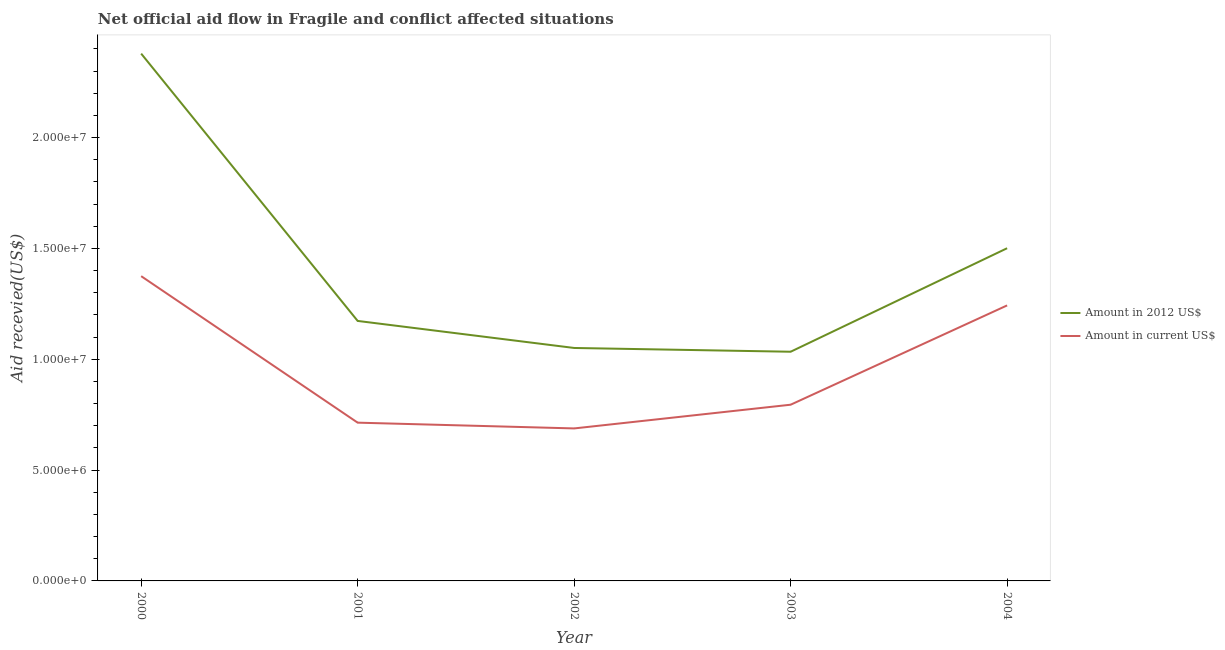How many different coloured lines are there?
Your answer should be very brief. 2. Does the line corresponding to amount of aid received(expressed in 2012 us$) intersect with the line corresponding to amount of aid received(expressed in us$)?
Make the answer very short. No. Is the number of lines equal to the number of legend labels?
Keep it short and to the point. Yes. What is the amount of aid received(expressed in 2012 us$) in 2000?
Offer a very short reply. 2.38e+07. Across all years, what is the maximum amount of aid received(expressed in 2012 us$)?
Make the answer very short. 2.38e+07. Across all years, what is the minimum amount of aid received(expressed in 2012 us$)?
Your answer should be very brief. 1.03e+07. In which year was the amount of aid received(expressed in us$) maximum?
Offer a very short reply. 2000. What is the total amount of aid received(expressed in 2012 us$) in the graph?
Your response must be concise. 7.14e+07. What is the difference between the amount of aid received(expressed in us$) in 2000 and that in 2001?
Ensure brevity in your answer.  6.61e+06. What is the difference between the amount of aid received(expressed in 2012 us$) in 2003 and the amount of aid received(expressed in us$) in 2002?
Your response must be concise. 3.46e+06. What is the average amount of aid received(expressed in us$) per year?
Make the answer very short. 9.63e+06. In the year 2003, what is the difference between the amount of aid received(expressed in us$) and amount of aid received(expressed in 2012 us$)?
Offer a very short reply. -2.39e+06. In how many years, is the amount of aid received(expressed in us$) greater than 20000000 US$?
Provide a short and direct response. 0. What is the ratio of the amount of aid received(expressed in us$) in 2002 to that in 2004?
Give a very brief answer. 0.55. What is the difference between the highest and the second highest amount of aid received(expressed in us$)?
Keep it short and to the point. 1.32e+06. What is the difference between the highest and the lowest amount of aid received(expressed in us$)?
Give a very brief answer. 6.87e+06. In how many years, is the amount of aid received(expressed in 2012 us$) greater than the average amount of aid received(expressed in 2012 us$) taken over all years?
Ensure brevity in your answer.  2. Does the amount of aid received(expressed in 2012 us$) monotonically increase over the years?
Offer a very short reply. No. Is the amount of aid received(expressed in us$) strictly greater than the amount of aid received(expressed in 2012 us$) over the years?
Ensure brevity in your answer.  No. Is the amount of aid received(expressed in 2012 us$) strictly less than the amount of aid received(expressed in us$) over the years?
Keep it short and to the point. No. How many lines are there?
Your answer should be very brief. 2. What is the difference between two consecutive major ticks on the Y-axis?
Give a very brief answer. 5.00e+06. Are the values on the major ticks of Y-axis written in scientific E-notation?
Offer a very short reply. Yes. Does the graph contain any zero values?
Your answer should be compact. No. Does the graph contain grids?
Make the answer very short. No. Where does the legend appear in the graph?
Give a very brief answer. Center right. What is the title of the graph?
Ensure brevity in your answer.  Net official aid flow in Fragile and conflict affected situations. What is the label or title of the X-axis?
Provide a succinct answer. Year. What is the label or title of the Y-axis?
Your response must be concise. Aid recevied(US$). What is the Aid recevied(US$) of Amount in 2012 US$ in 2000?
Your answer should be compact. 2.38e+07. What is the Aid recevied(US$) in Amount in current US$ in 2000?
Give a very brief answer. 1.38e+07. What is the Aid recevied(US$) in Amount in 2012 US$ in 2001?
Your answer should be compact. 1.17e+07. What is the Aid recevied(US$) in Amount in current US$ in 2001?
Your answer should be very brief. 7.14e+06. What is the Aid recevied(US$) of Amount in 2012 US$ in 2002?
Provide a succinct answer. 1.05e+07. What is the Aid recevied(US$) in Amount in current US$ in 2002?
Keep it short and to the point. 6.88e+06. What is the Aid recevied(US$) of Amount in 2012 US$ in 2003?
Provide a succinct answer. 1.03e+07. What is the Aid recevied(US$) in Amount in current US$ in 2003?
Ensure brevity in your answer.  7.95e+06. What is the Aid recevied(US$) in Amount in 2012 US$ in 2004?
Offer a terse response. 1.50e+07. What is the Aid recevied(US$) in Amount in current US$ in 2004?
Provide a short and direct response. 1.24e+07. Across all years, what is the maximum Aid recevied(US$) of Amount in 2012 US$?
Offer a very short reply. 2.38e+07. Across all years, what is the maximum Aid recevied(US$) in Amount in current US$?
Make the answer very short. 1.38e+07. Across all years, what is the minimum Aid recevied(US$) of Amount in 2012 US$?
Give a very brief answer. 1.03e+07. Across all years, what is the minimum Aid recevied(US$) in Amount in current US$?
Your response must be concise. 6.88e+06. What is the total Aid recevied(US$) in Amount in 2012 US$ in the graph?
Make the answer very short. 7.14e+07. What is the total Aid recevied(US$) in Amount in current US$ in the graph?
Ensure brevity in your answer.  4.82e+07. What is the difference between the Aid recevied(US$) in Amount in 2012 US$ in 2000 and that in 2001?
Keep it short and to the point. 1.21e+07. What is the difference between the Aid recevied(US$) in Amount in current US$ in 2000 and that in 2001?
Give a very brief answer. 6.61e+06. What is the difference between the Aid recevied(US$) in Amount in 2012 US$ in 2000 and that in 2002?
Provide a short and direct response. 1.33e+07. What is the difference between the Aid recevied(US$) of Amount in current US$ in 2000 and that in 2002?
Provide a short and direct response. 6.87e+06. What is the difference between the Aid recevied(US$) of Amount in 2012 US$ in 2000 and that in 2003?
Ensure brevity in your answer.  1.34e+07. What is the difference between the Aid recevied(US$) of Amount in current US$ in 2000 and that in 2003?
Provide a short and direct response. 5.80e+06. What is the difference between the Aid recevied(US$) in Amount in 2012 US$ in 2000 and that in 2004?
Offer a terse response. 8.78e+06. What is the difference between the Aid recevied(US$) of Amount in current US$ in 2000 and that in 2004?
Your answer should be compact. 1.32e+06. What is the difference between the Aid recevied(US$) in Amount in 2012 US$ in 2001 and that in 2002?
Provide a succinct answer. 1.22e+06. What is the difference between the Aid recevied(US$) in Amount in current US$ in 2001 and that in 2002?
Give a very brief answer. 2.60e+05. What is the difference between the Aid recevied(US$) in Amount in 2012 US$ in 2001 and that in 2003?
Your answer should be very brief. 1.39e+06. What is the difference between the Aid recevied(US$) of Amount in current US$ in 2001 and that in 2003?
Your answer should be very brief. -8.10e+05. What is the difference between the Aid recevied(US$) of Amount in 2012 US$ in 2001 and that in 2004?
Your answer should be very brief. -3.28e+06. What is the difference between the Aid recevied(US$) of Amount in current US$ in 2001 and that in 2004?
Give a very brief answer. -5.29e+06. What is the difference between the Aid recevied(US$) of Amount in 2012 US$ in 2002 and that in 2003?
Keep it short and to the point. 1.70e+05. What is the difference between the Aid recevied(US$) in Amount in current US$ in 2002 and that in 2003?
Your response must be concise. -1.07e+06. What is the difference between the Aid recevied(US$) of Amount in 2012 US$ in 2002 and that in 2004?
Keep it short and to the point. -4.50e+06. What is the difference between the Aid recevied(US$) of Amount in current US$ in 2002 and that in 2004?
Make the answer very short. -5.55e+06. What is the difference between the Aid recevied(US$) in Amount in 2012 US$ in 2003 and that in 2004?
Offer a very short reply. -4.67e+06. What is the difference between the Aid recevied(US$) in Amount in current US$ in 2003 and that in 2004?
Offer a terse response. -4.48e+06. What is the difference between the Aid recevied(US$) in Amount in 2012 US$ in 2000 and the Aid recevied(US$) in Amount in current US$ in 2001?
Provide a short and direct response. 1.66e+07. What is the difference between the Aid recevied(US$) in Amount in 2012 US$ in 2000 and the Aid recevied(US$) in Amount in current US$ in 2002?
Offer a very short reply. 1.69e+07. What is the difference between the Aid recevied(US$) of Amount in 2012 US$ in 2000 and the Aid recevied(US$) of Amount in current US$ in 2003?
Provide a short and direct response. 1.58e+07. What is the difference between the Aid recevied(US$) of Amount in 2012 US$ in 2000 and the Aid recevied(US$) of Amount in current US$ in 2004?
Keep it short and to the point. 1.14e+07. What is the difference between the Aid recevied(US$) of Amount in 2012 US$ in 2001 and the Aid recevied(US$) of Amount in current US$ in 2002?
Your answer should be compact. 4.85e+06. What is the difference between the Aid recevied(US$) of Amount in 2012 US$ in 2001 and the Aid recevied(US$) of Amount in current US$ in 2003?
Offer a very short reply. 3.78e+06. What is the difference between the Aid recevied(US$) of Amount in 2012 US$ in 2001 and the Aid recevied(US$) of Amount in current US$ in 2004?
Your response must be concise. -7.00e+05. What is the difference between the Aid recevied(US$) of Amount in 2012 US$ in 2002 and the Aid recevied(US$) of Amount in current US$ in 2003?
Your answer should be very brief. 2.56e+06. What is the difference between the Aid recevied(US$) in Amount in 2012 US$ in 2002 and the Aid recevied(US$) in Amount in current US$ in 2004?
Offer a very short reply. -1.92e+06. What is the difference between the Aid recevied(US$) of Amount in 2012 US$ in 2003 and the Aid recevied(US$) of Amount in current US$ in 2004?
Your answer should be very brief. -2.09e+06. What is the average Aid recevied(US$) of Amount in 2012 US$ per year?
Give a very brief answer. 1.43e+07. What is the average Aid recevied(US$) of Amount in current US$ per year?
Provide a short and direct response. 9.63e+06. In the year 2000, what is the difference between the Aid recevied(US$) of Amount in 2012 US$ and Aid recevied(US$) of Amount in current US$?
Offer a terse response. 1.00e+07. In the year 2001, what is the difference between the Aid recevied(US$) in Amount in 2012 US$ and Aid recevied(US$) in Amount in current US$?
Your answer should be very brief. 4.59e+06. In the year 2002, what is the difference between the Aid recevied(US$) in Amount in 2012 US$ and Aid recevied(US$) in Amount in current US$?
Keep it short and to the point. 3.63e+06. In the year 2003, what is the difference between the Aid recevied(US$) in Amount in 2012 US$ and Aid recevied(US$) in Amount in current US$?
Keep it short and to the point. 2.39e+06. In the year 2004, what is the difference between the Aid recevied(US$) of Amount in 2012 US$ and Aid recevied(US$) of Amount in current US$?
Offer a very short reply. 2.58e+06. What is the ratio of the Aid recevied(US$) in Amount in 2012 US$ in 2000 to that in 2001?
Offer a terse response. 2.03. What is the ratio of the Aid recevied(US$) in Amount in current US$ in 2000 to that in 2001?
Offer a very short reply. 1.93. What is the ratio of the Aid recevied(US$) of Amount in 2012 US$ in 2000 to that in 2002?
Keep it short and to the point. 2.26. What is the ratio of the Aid recevied(US$) of Amount in current US$ in 2000 to that in 2002?
Your response must be concise. 2. What is the ratio of the Aid recevied(US$) of Amount in 2012 US$ in 2000 to that in 2003?
Offer a very short reply. 2.3. What is the ratio of the Aid recevied(US$) of Amount in current US$ in 2000 to that in 2003?
Make the answer very short. 1.73. What is the ratio of the Aid recevied(US$) of Amount in 2012 US$ in 2000 to that in 2004?
Your answer should be compact. 1.58. What is the ratio of the Aid recevied(US$) in Amount in current US$ in 2000 to that in 2004?
Make the answer very short. 1.11. What is the ratio of the Aid recevied(US$) of Amount in 2012 US$ in 2001 to that in 2002?
Provide a succinct answer. 1.12. What is the ratio of the Aid recevied(US$) in Amount in current US$ in 2001 to that in 2002?
Your answer should be compact. 1.04. What is the ratio of the Aid recevied(US$) of Amount in 2012 US$ in 2001 to that in 2003?
Your answer should be very brief. 1.13. What is the ratio of the Aid recevied(US$) in Amount in current US$ in 2001 to that in 2003?
Give a very brief answer. 0.9. What is the ratio of the Aid recevied(US$) in Amount in 2012 US$ in 2001 to that in 2004?
Offer a terse response. 0.78. What is the ratio of the Aid recevied(US$) of Amount in current US$ in 2001 to that in 2004?
Provide a succinct answer. 0.57. What is the ratio of the Aid recevied(US$) of Amount in 2012 US$ in 2002 to that in 2003?
Give a very brief answer. 1.02. What is the ratio of the Aid recevied(US$) in Amount in current US$ in 2002 to that in 2003?
Your answer should be very brief. 0.87. What is the ratio of the Aid recevied(US$) in Amount in 2012 US$ in 2002 to that in 2004?
Make the answer very short. 0.7. What is the ratio of the Aid recevied(US$) in Amount in current US$ in 2002 to that in 2004?
Ensure brevity in your answer.  0.55. What is the ratio of the Aid recevied(US$) in Amount in 2012 US$ in 2003 to that in 2004?
Give a very brief answer. 0.69. What is the ratio of the Aid recevied(US$) of Amount in current US$ in 2003 to that in 2004?
Keep it short and to the point. 0.64. What is the difference between the highest and the second highest Aid recevied(US$) of Amount in 2012 US$?
Ensure brevity in your answer.  8.78e+06. What is the difference between the highest and the second highest Aid recevied(US$) of Amount in current US$?
Ensure brevity in your answer.  1.32e+06. What is the difference between the highest and the lowest Aid recevied(US$) of Amount in 2012 US$?
Provide a short and direct response. 1.34e+07. What is the difference between the highest and the lowest Aid recevied(US$) in Amount in current US$?
Your answer should be very brief. 6.87e+06. 